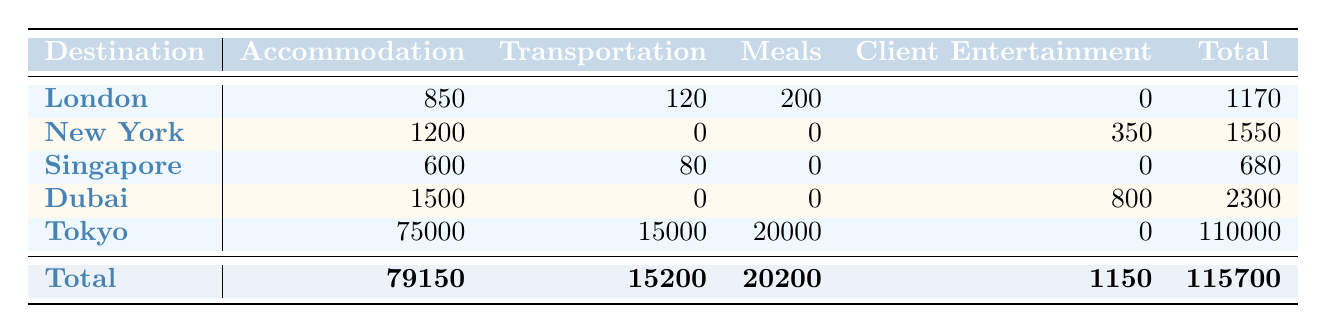What is the total amount spent on accommodation for all trips? To find the total spent on accommodation, we sum the amounts in the "Accommodation" column: 850 (London) + 1200 (New York) + 600 (Singapore) + 1500 (Dubai) + 75000 (Tokyo) = 79150.
Answer: 79150 Which trip had the highest total expenses? Looking at the "Total" column, the values are 1170 (London), 1550 (New York), 680 (Singapore), 2300 (Dubai), and 110000 (Tokyo). The highest value is 110000 for the Tokyo trip.
Answer: Tokyo Did any trip have client entertainment expenses? We check the "Client Entertainment" column. It shows that only the New York trip (350) and the Dubai trip (800) had expenses in this category. Hence, the answer is yes.
Answer: Yes What was the average transportation expense across all trips? The transportation expenses are 120 (London), 0 (New York), 80 (Singapore), 0 (Dubai), and 15000 (Tokyo). So, we sum them: 120 + 0 + 80 + 0 + 15000 = 150200. There are 5 trips, so the average is 150200 / 5 = 30040.
Answer: 30040 What percentage of the total expenses was spent on meals? The total amount for meals is 200 (London) + 0 (New York) + 0 (Singapore) + 0 (Dubai) + 20000 (Tokyo) = 20200. The overall total expenses from "Total" is 115700. To find the percentage, we calculate (20200 / 115700) * 100 = 17.43%.
Answer: 17.43% 